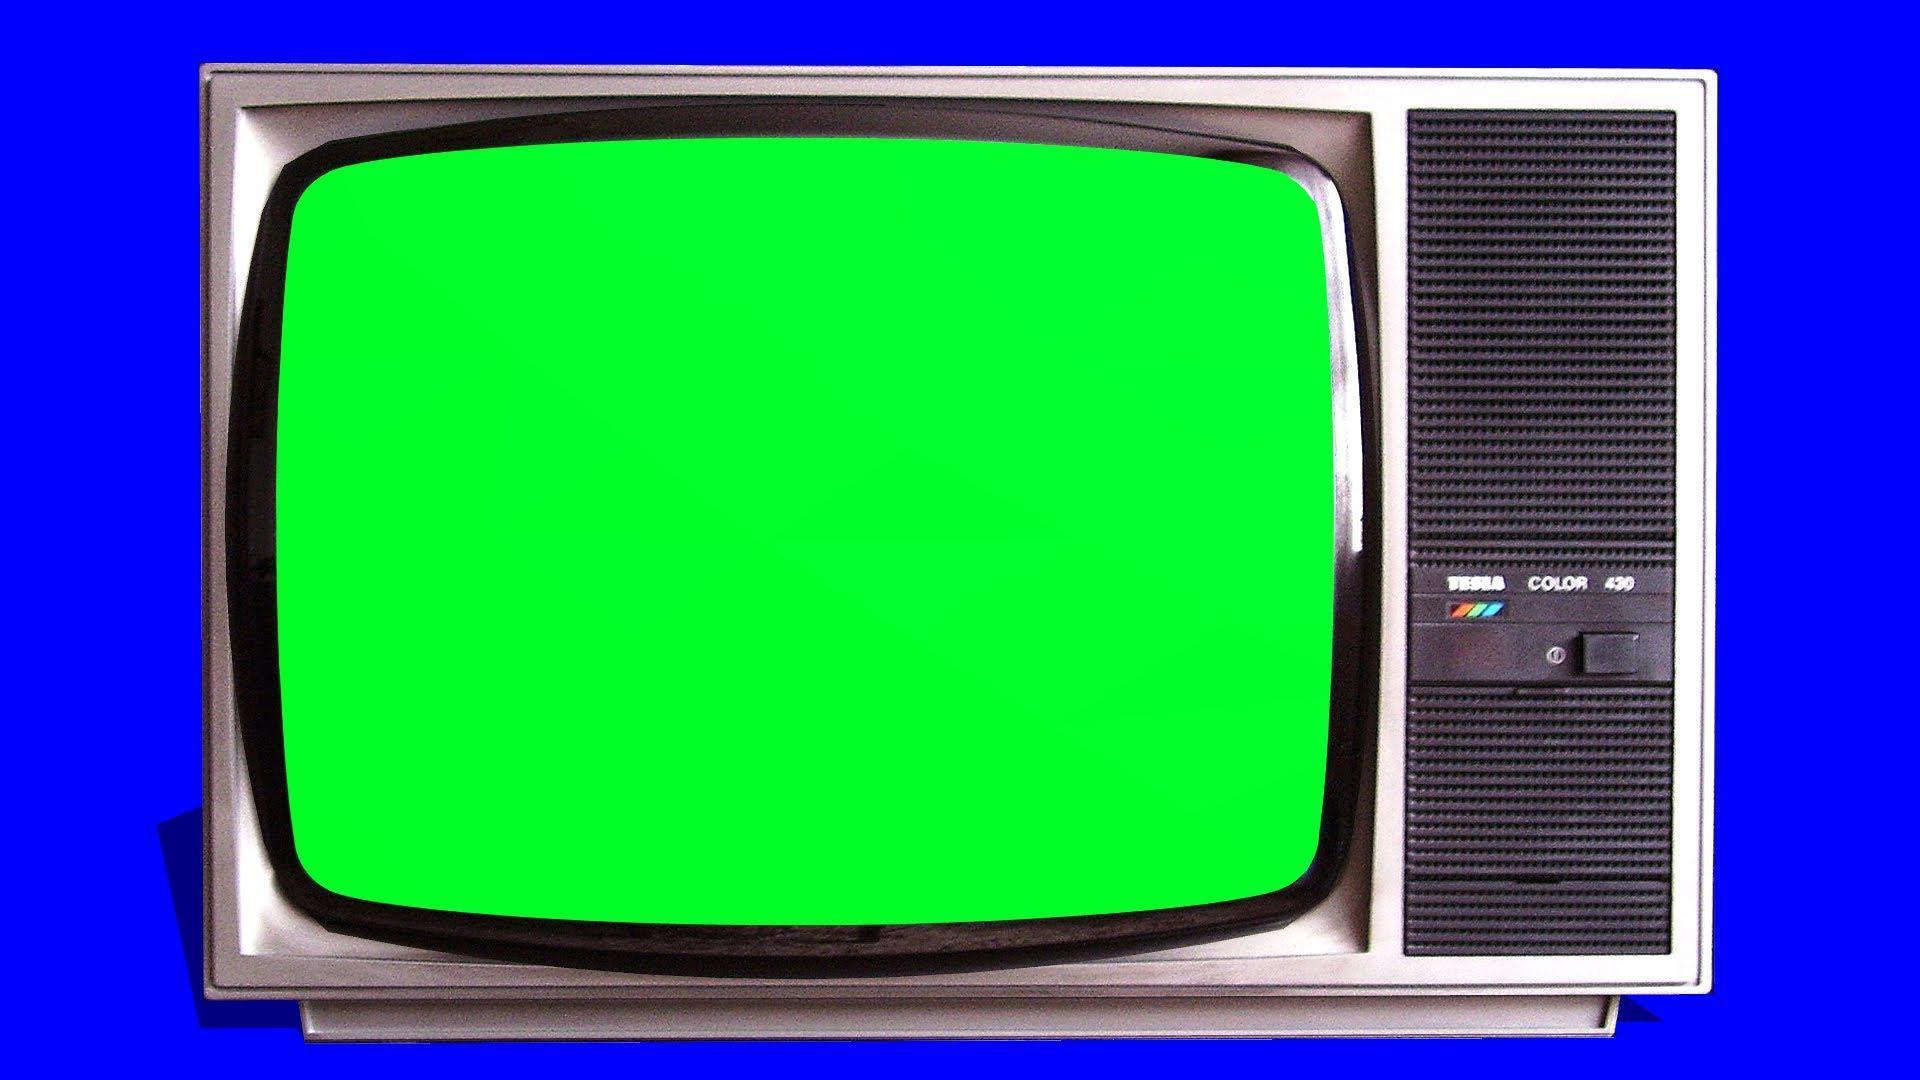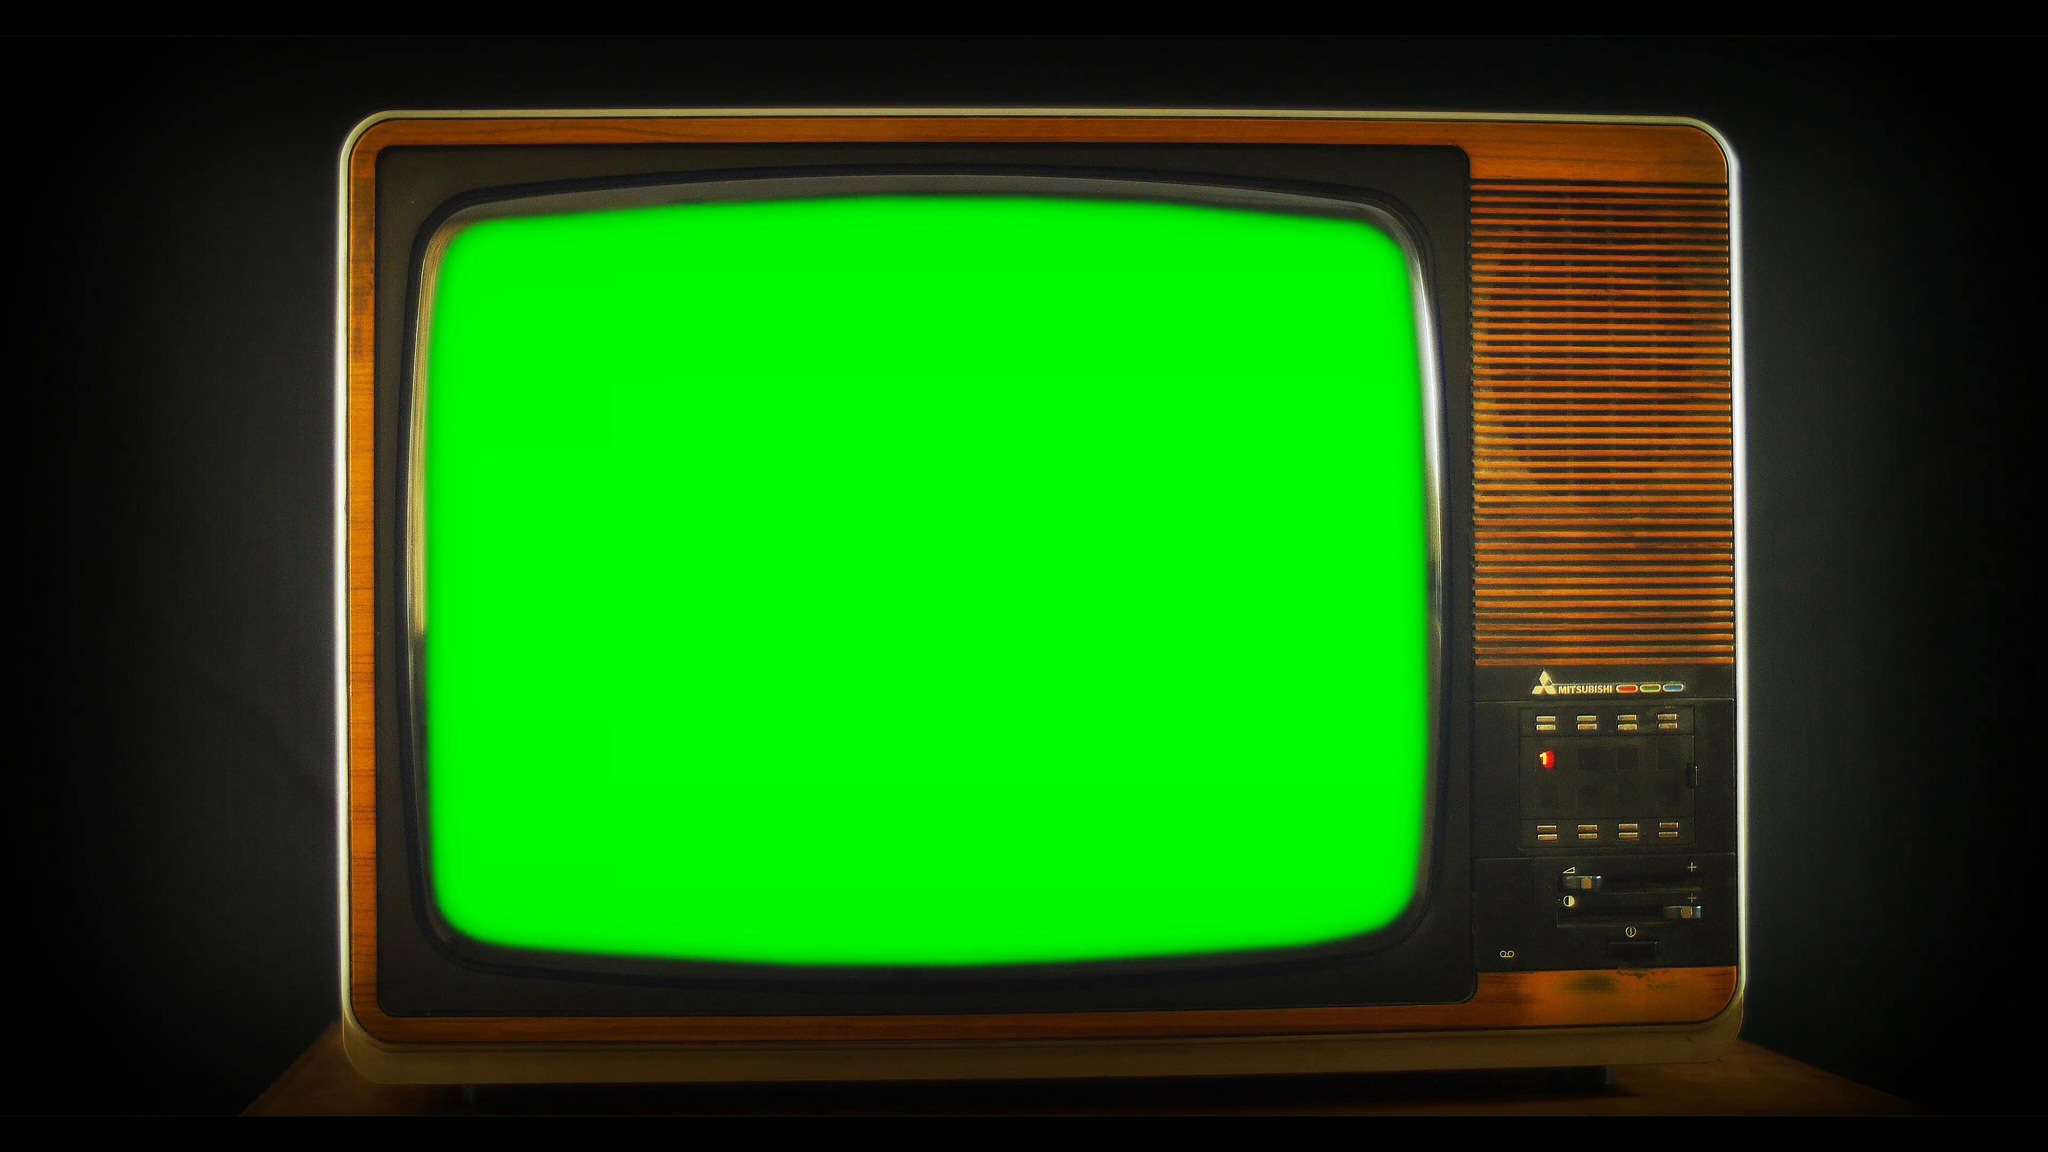The first image is the image on the left, the second image is the image on the right. Assess this claim about the two images: "A single television with a bright green screen has a blue background.". Correct or not? Answer yes or no. Yes. The first image is the image on the left, the second image is the image on the right. Examine the images to the left and right. Is the description "One glowing green TV screen is modern, flat and wide, and the other glowing green screen is in an old-fashioned box-like TV set." accurate? Answer yes or no. No. 